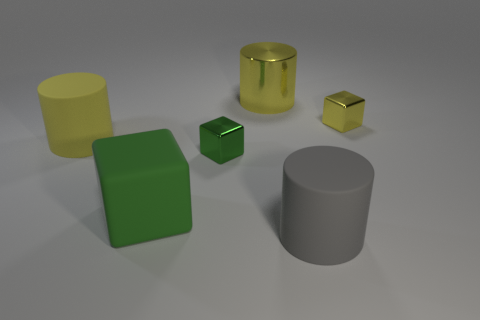There is a yellow cylinder that is the same material as the gray object; what is its size?
Offer a terse response. Large. What is the size of the cylinder that is in front of the yellow shiny cylinder and behind the large green object?
Make the answer very short. Large. Does the shiny thing that is on the right side of the big shiny cylinder have the same size as the yellow cylinder right of the big green rubber thing?
Keep it short and to the point. No. The shiny cylinder has what color?
Provide a short and direct response. Yellow. Do the yellow rubber object and the yellow metal object on the right side of the large gray matte thing have the same size?
Give a very brief answer. No. What number of metallic objects are either small cyan cylinders or small objects?
Your answer should be compact. 2. Do the large metal object and the large matte cylinder behind the large rubber cube have the same color?
Ensure brevity in your answer.  Yes. What is the shape of the big green rubber object?
Offer a very short reply. Cube. How big is the block behind the metallic block left of the big yellow cylinder that is to the right of the big green thing?
Make the answer very short. Small. What number of other things are there of the same shape as the big metallic thing?
Make the answer very short. 2. 